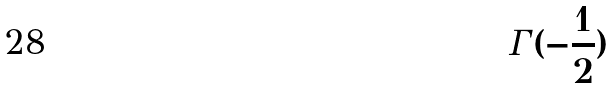Convert formula to latex. <formula><loc_0><loc_0><loc_500><loc_500>\Gamma ( - \frac { 1 } { 2 } )</formula> 